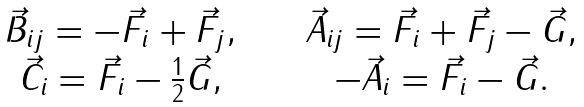<formula> <loc_0><loc_0><loc_500><loc_500>\begin{array} { c c c } \vec { B } _ { i j } = - \vec { F } _ { i } + \vec { F } _ { j } , & \quad & \vec { A } _ { i j } = \vec { F } _ { i } + \vec { F } _ { j } - \vec { G } , \\ \vec { C } _ { i } = \vec { F } _ { i } - \frac { 1 } { 2 } \vec { G } , & \quad & - \vec { A } _ { i } = \vec { F } _ { i } - \vec { G } . \\ \end{array}</formula> 